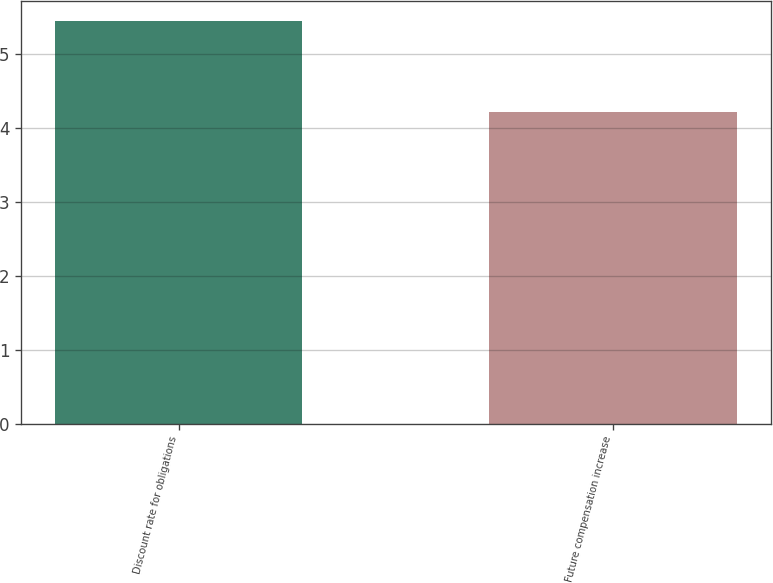<chart> <loc_0><loc_0><loc_500><loc_500><bar_chart><fcel>Discount rate for obligations<fcel>Future compensation increase<nl><fcel>5.44<fcel>4.21<nl></chart> 